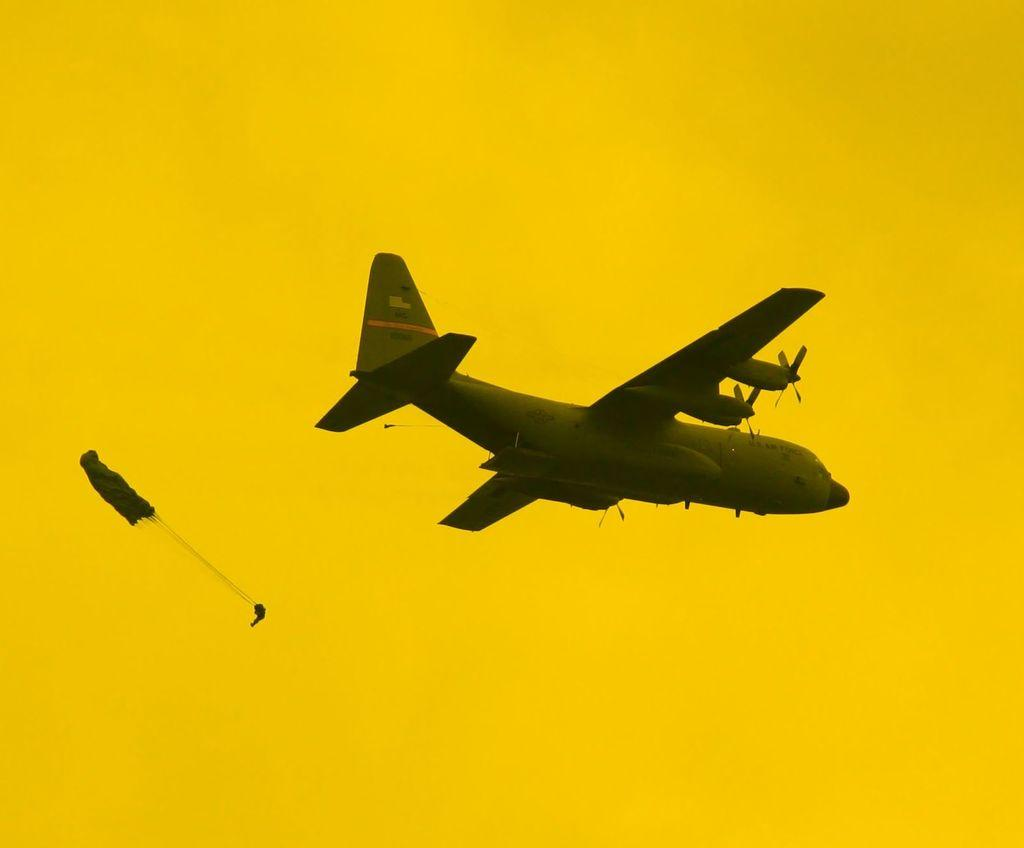What is the main subject of the image? There is an aeroplane in the image. Can you describe any other objects in the image? There is an object in the image, but its specific details are not mentioned in the facts. What color is the background of the image? The background of the image is yellow. How many cherries are on the father's bike in the image? There is no mention of cherries, a father, or bikes in the image, so this question cannot be answered. 